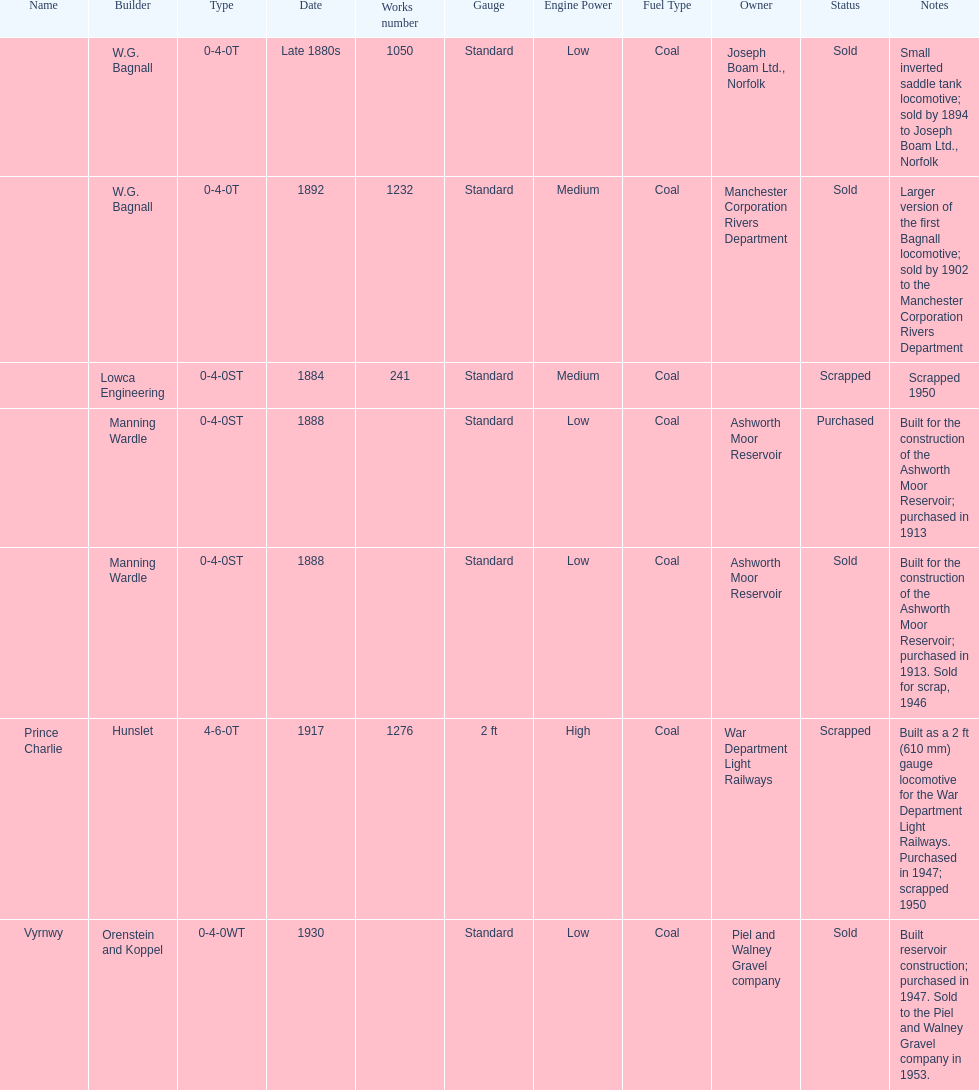How many locomotives were built for the construction of the ashworth moor reservoir? 2. 